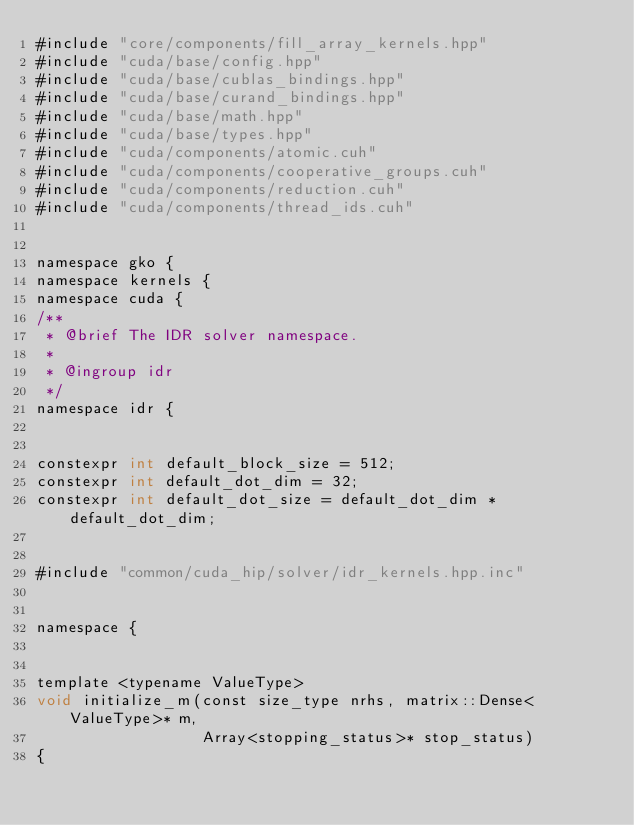<code> <loc_0><loc_0><loc_500><loc_500><_Cuda_>#include "core/components/fill_array_kernels.hpp"
#include "cuda/base/config.hpp"
#include "cuda/base/cublas_bindings.hpp"
#include "cuda/base/curand_bindings.hpp"
#include "cuda/base/math.hpp"
#include "cuda/base/types.hpp"
#include "cuda/components/atomic.cuh"
#include "cuda/components/cooperative_groups.cuh"
#include "cuda/components/reduction.cuh"
#include "cuda/components/thread_ids.cuh"


namespace gko {
namespace kernels {
namespace cuda {
/**
 * @brief The IDR solver namespace.
 *
 * @ingroup idr
 */
namespace idr {


constexpr int default_block_size = 512;
constexpr int default_dot_dim = 32;
constexpr int default_dot_size = default_dot_dim * default_dot_dim;


#include "common/cuda_hip/solver/idr_kernels.hpp.inc"


namespace {


template <typename ValueType>
void initialize_m(const size_type nrhs, matrix::Dense<ValueType>* m,
                  Array<stopping_status>* stop_status)
{</code> 